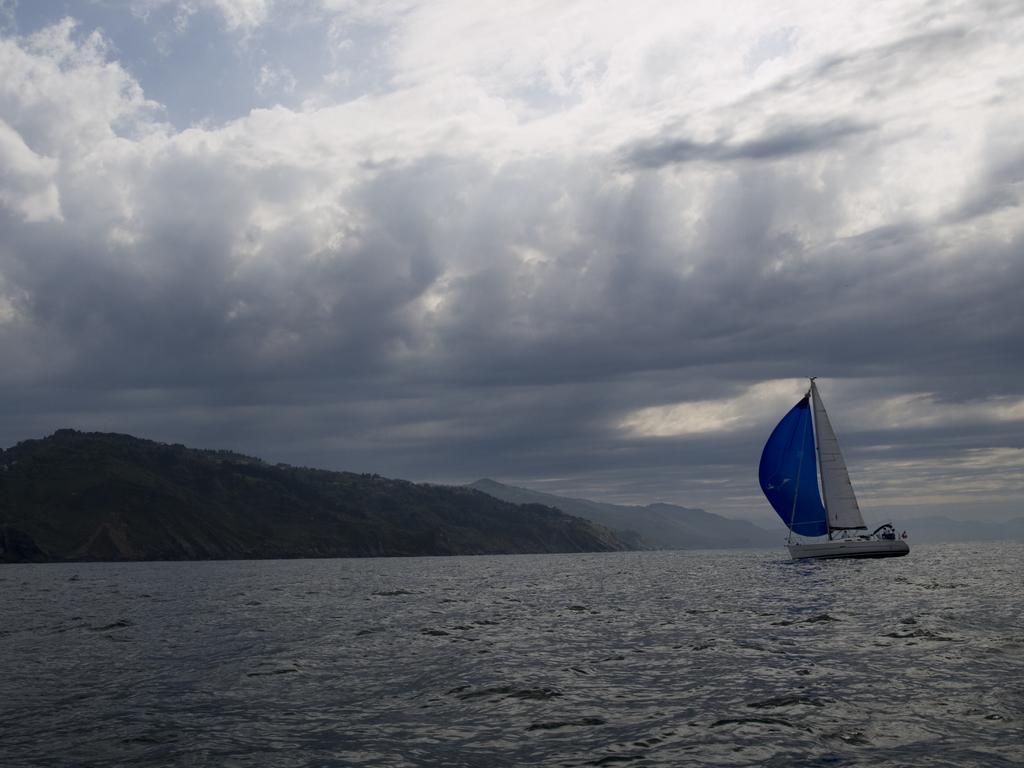In one or two sentences, can you explain what this image depicts? In this image, we can see water, on the right side, we can see a boat on the water. We can see mountains, at the top we can see the sky is cloudy. 